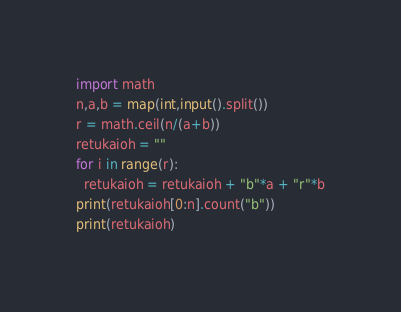<code> <loc_0><loc_0><loc_500><loc_500><_Python_>import math
n,a,b = map(int,input().split())
r = math.ceil(n/(a+b))
retukaioh = ""
for i in range(r):
  retukaioh = retukaioh + "b"*a + "r"*b
print(retukaioh[0:n].count("b"))
print(retukaioh)</code> 